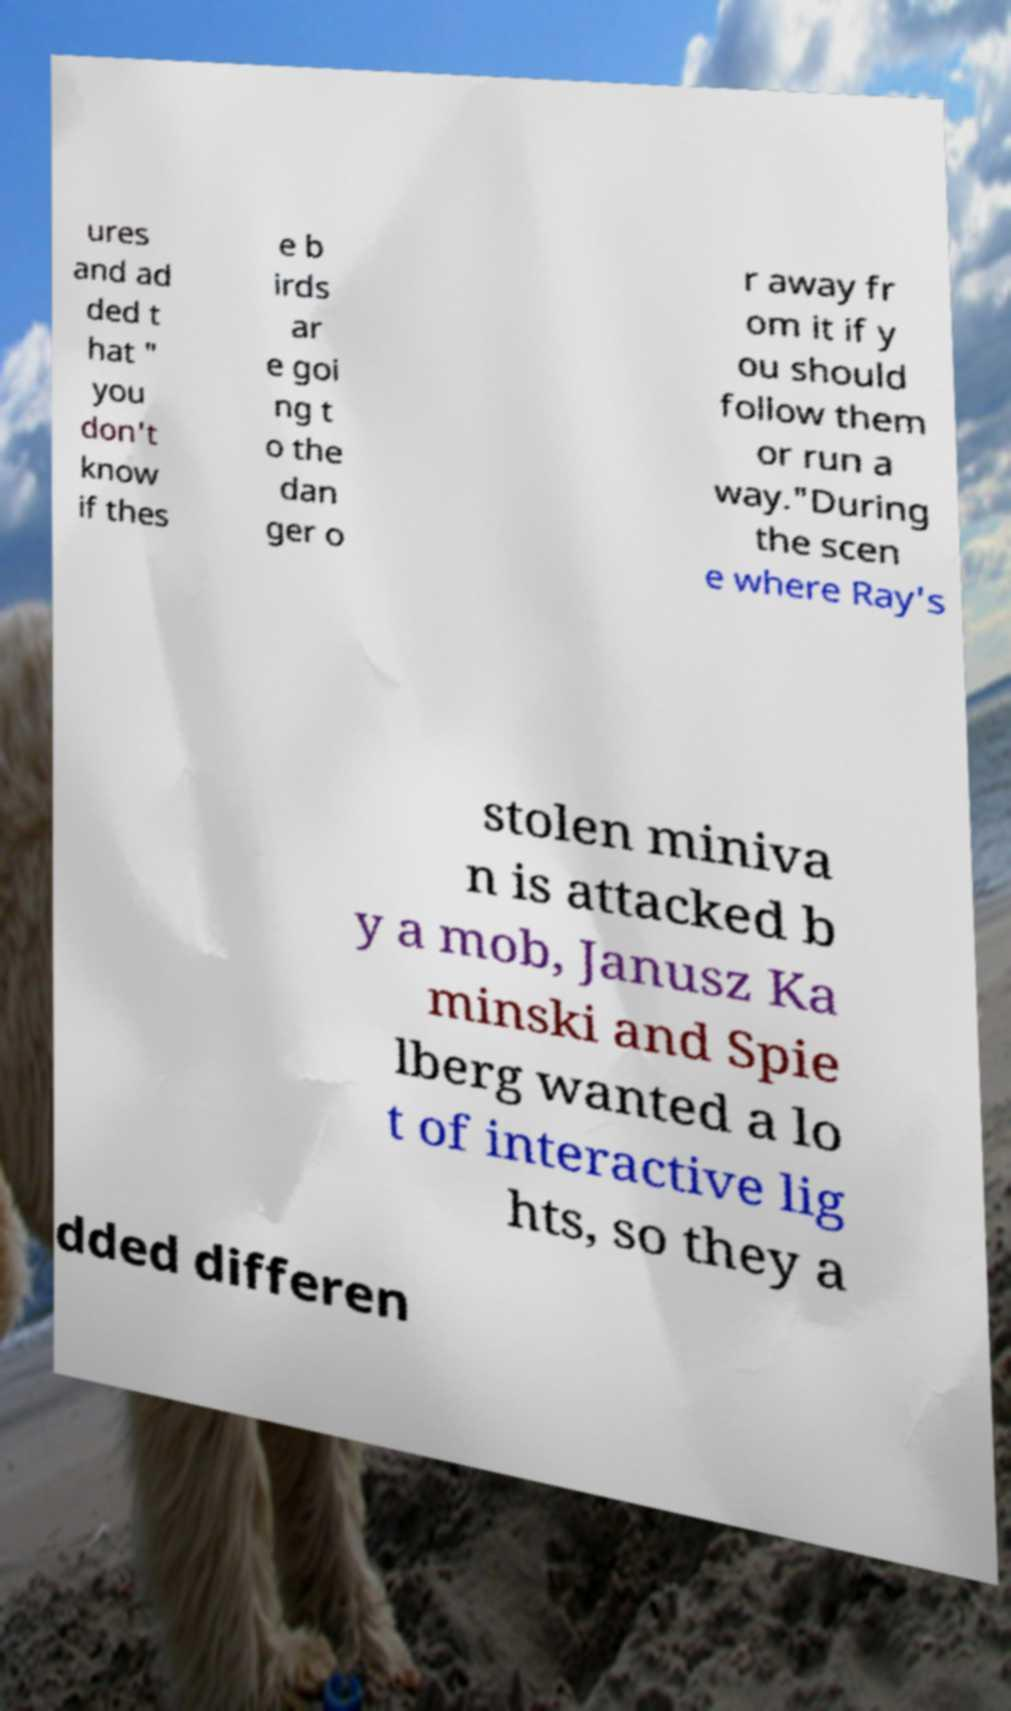Could you assist in decoding the text presented in this image and type it out clearly? ures and ad ded t hat " you don't know if thes e b irds ar e goi ng t o the dan ger o r away fr om it if y ou should follow them or run a way."During the scen e where Ray's stolen miniva n is attacked b y a mob, Janusz Ka minski and Spie lberg wanted a lo t of interactive lig hts, so they a dded differen 